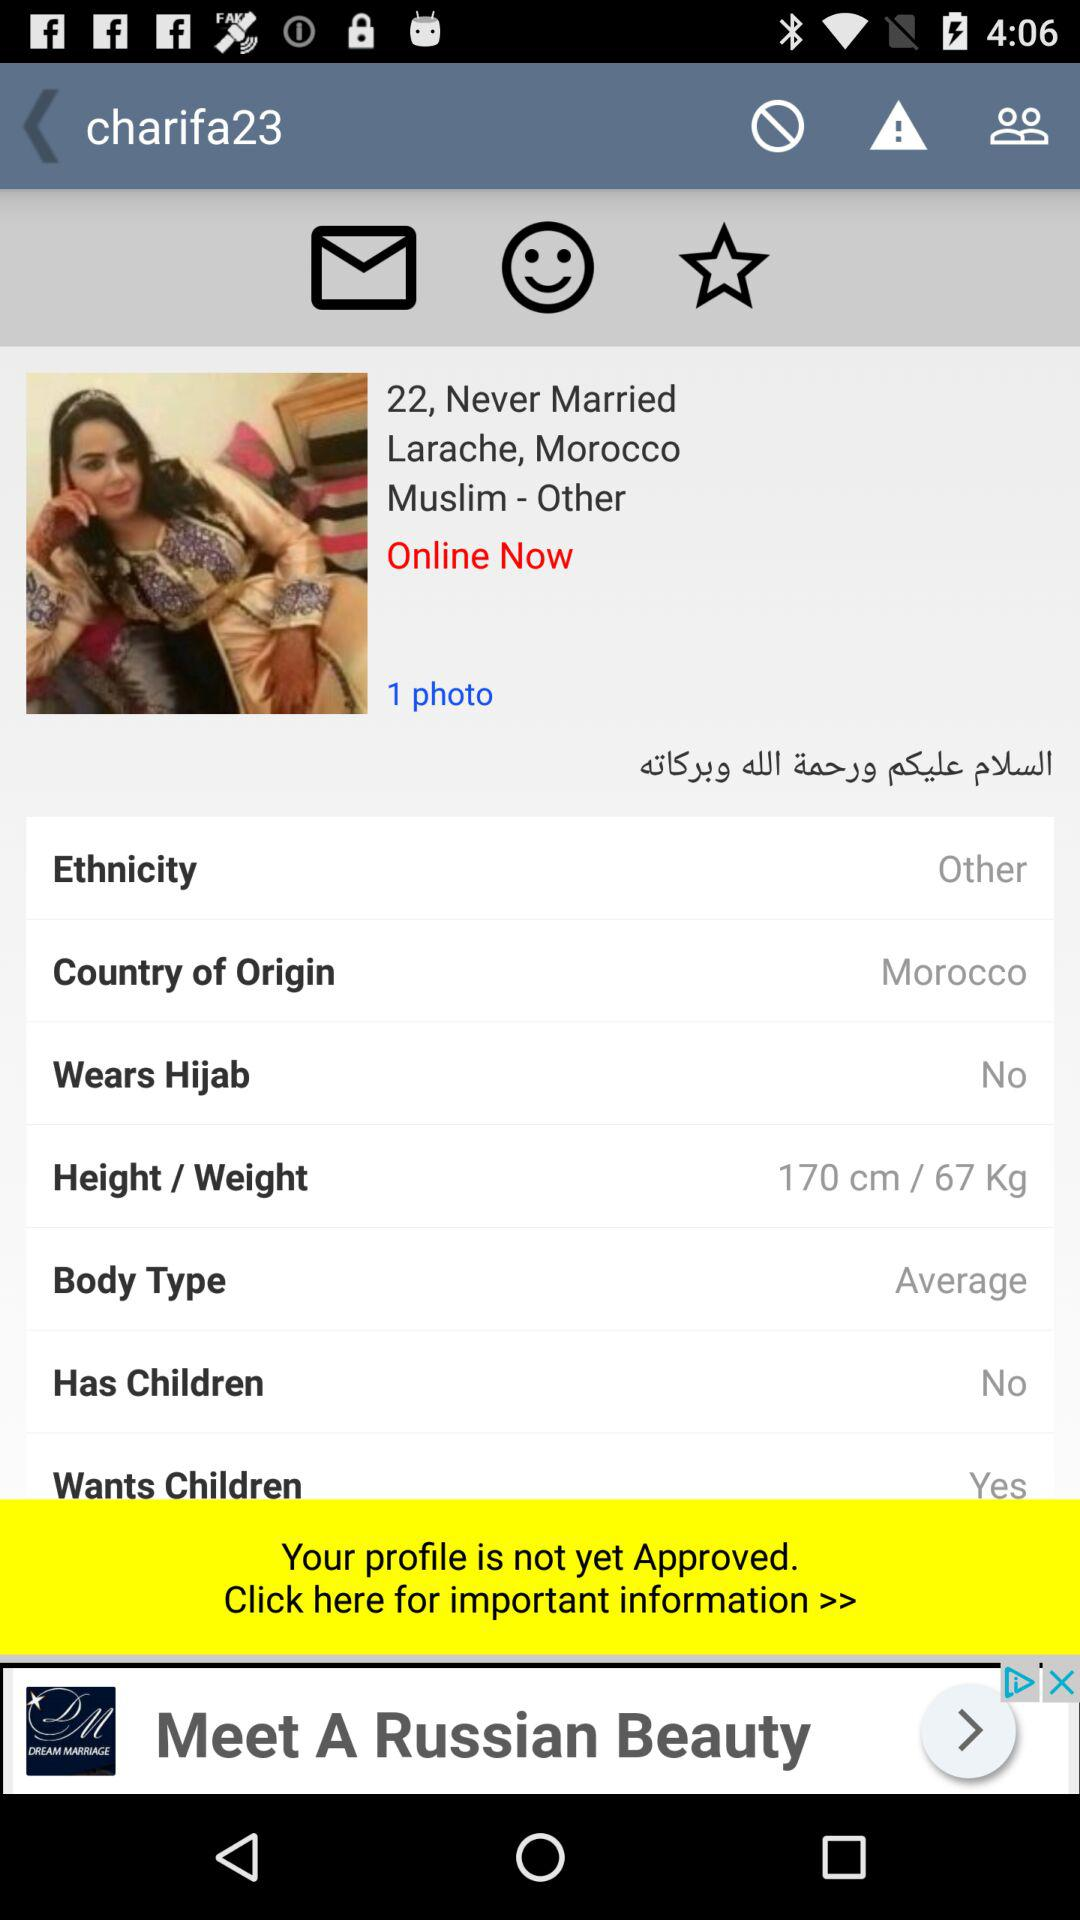What is the name of the user? The name of the user is "charifa23". 